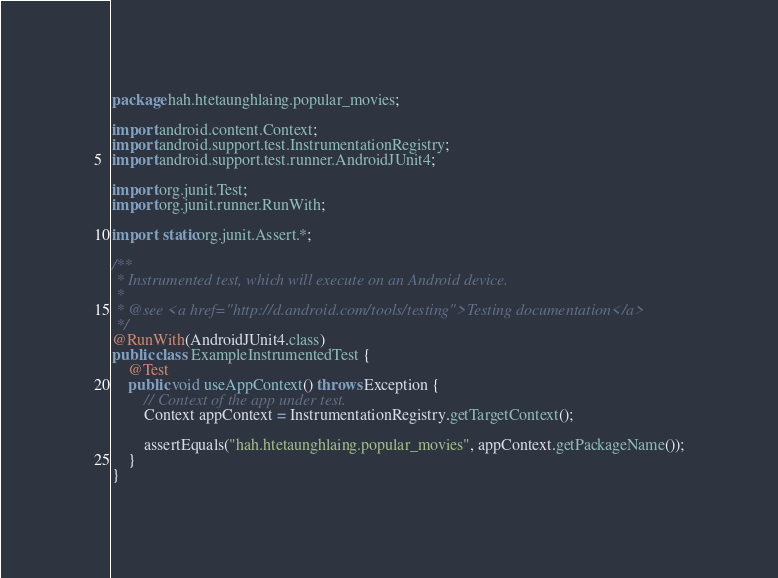<code> <loc_0><loc_0><loc_500><loc_500><_Java_>package hah.htetaunghlaing.popular_movies;

import android.content.Context;
import android.support.test.InstrumentationRegistry;
import android.support.test.runner.AndroidJUnit4;

import org.junit.Test;
import org.junit.runner.RunWith;

import static org.junit.Assert.*;

/**
 * Instrumented test, which will execute on an Android device.
 *
 * @see <a href="http://d.android.com/tools/testing">Testing documentation</a>
 */
@RunWith(AndroidJUnit4.class)
public class ExampleInstrumentedTest {
    @Test
    public void useAppContext() throws Exception {
        // Context of the app under test.
        Context appContext = InstrumentationRegistry.getTargetContext();

        assertEquals("hah.htetaunghlaing.popular_movies", appContext.getPackageName());
    }
}
</code> 